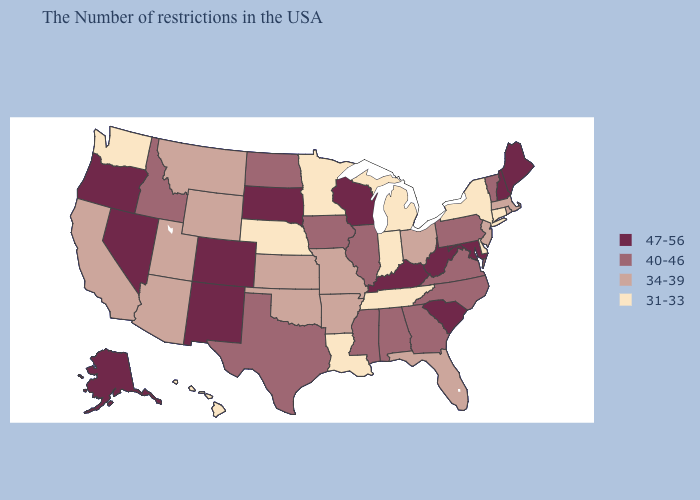Does Maryland have the same value as South Dakota?
Concise answer only. Yes. Does Minnesota have the lowest value in the USA?
Give a very brief answer. Yes. Name the states that have a value in the range 47-56?
Write a very short answer. Maine, New Hampshire, Maryland, South Carolina, West Virginia, Kentucky, Wisconsin, South Dakota, Colorado, New Mexico, Nevada, Oregon, Alaska. What is the value of Oklahoma?
Give a very brief answer. 34-39. Name the states that have a value in the range 34-39?
Quick response, please. Massachusetts, Rhode Island, New Jersey, Ohio, Florida, Missouri, Arkansas, Kansas, Oklahoma, Wyoming, Utah, Montana, Arizona, California. Does Florida have a lower value than Connecticut?
Answer briefly. No. What is the value of Idaho?
Answer briefly. 40-46. Does the map have missing data?
Write a very short answer. No. What is the value of Wisconsin?
Answer briefly. 47-56. Name the states that have a value in the range 47-56?
Give a very brief answer. Maine, New Hampshire, Maryland, South Carolina, West Virginia, Kentucky, Wisconsin, South Dakota, Colorado, New Mexico, Nevada, Oregon, Alaska. Which states have the lowest value in the USA?
Concise answer only. Connecticut, New York, Delaware, Michigan, Indiana, Tennessee, Louisiana, Minnesota, Nebraska, Washington, Hawaii. Does Illinois have the highest value in the USA?
Write a very short answer. No. Is the legend a continuous bar?
Be succinct. No. Does North Dakota have a lower value than Missouri?
Write a very short answer. No. Is the legend a continuous bar?
Write a very short answer. No. 